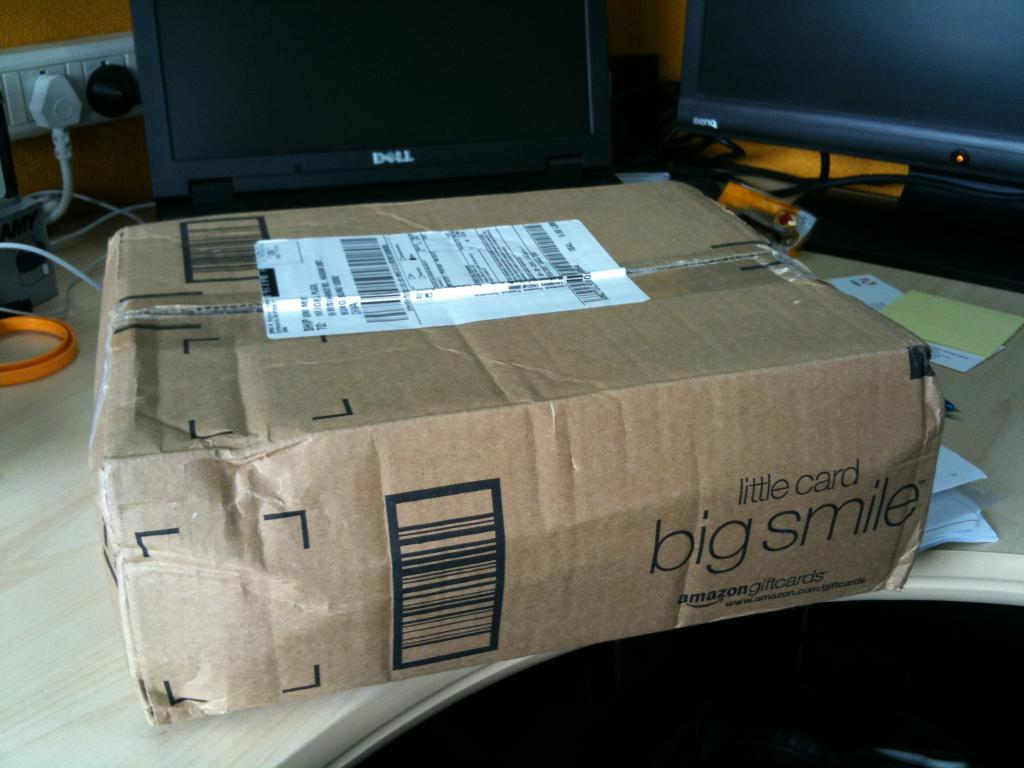<image>
Write a terse but informative summary of the picture. An Amazon cardboard box with a white packaging label on a desk top. 